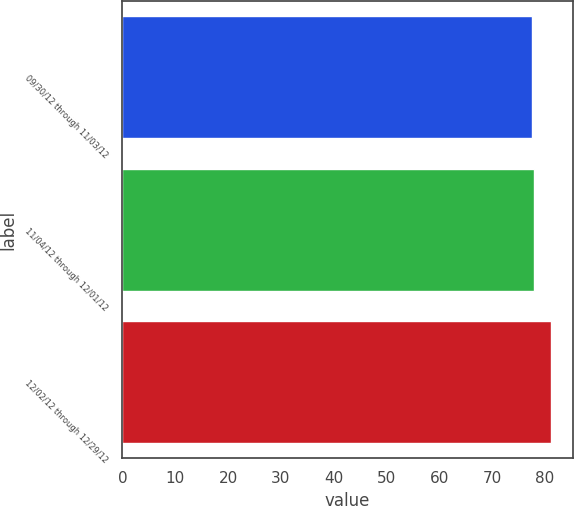<chart> <loc_0><loc_0><loc_500><loc_500><bar_chart><fcel>09/30/12 through 11/03/12<fcel>11/04/12 through 12/01/12<fcel>12/02/12 through 12/29/12<nl><fcel>77.5<fcel>78<fcel>81.16<nl></chart> 